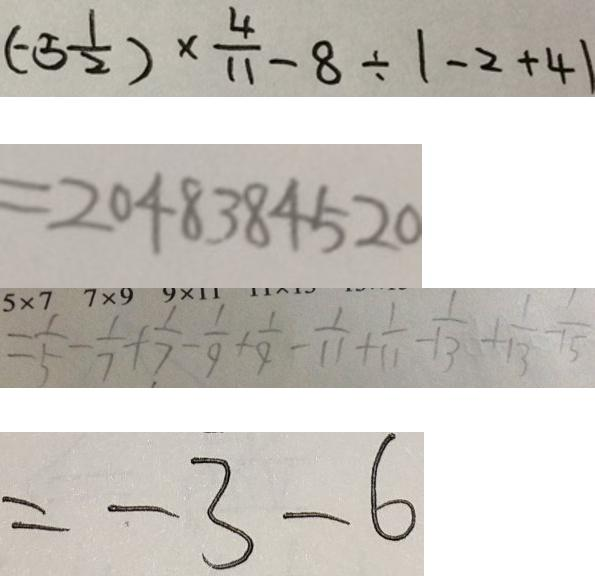<formula> <loc_0><loc_0><loc_500><loc_500>( - 5 \frac { 1 } { 2 } ) \times \frac { 4 } { 1 1 } - 8 \div \vert - 2 + 4 \vert 
 = 2 0 4 8 3 8 4 5 2 0 
 = \frac { 1 } { 5 } - \frac { 1 } { 7 } + \frac { 1 } { 7 } - \frac { 1 } { 9 } + \frac { 1 } { 9 } - \frac { 1 } { 1 1 } + \frac { 1 } { 1 1 } - \frac { 1 } { 1 3 } + \frac { 1 } { 1 3 } - \frac { 1 } { 1 5 } 
 = - 3 - 6</formula> 